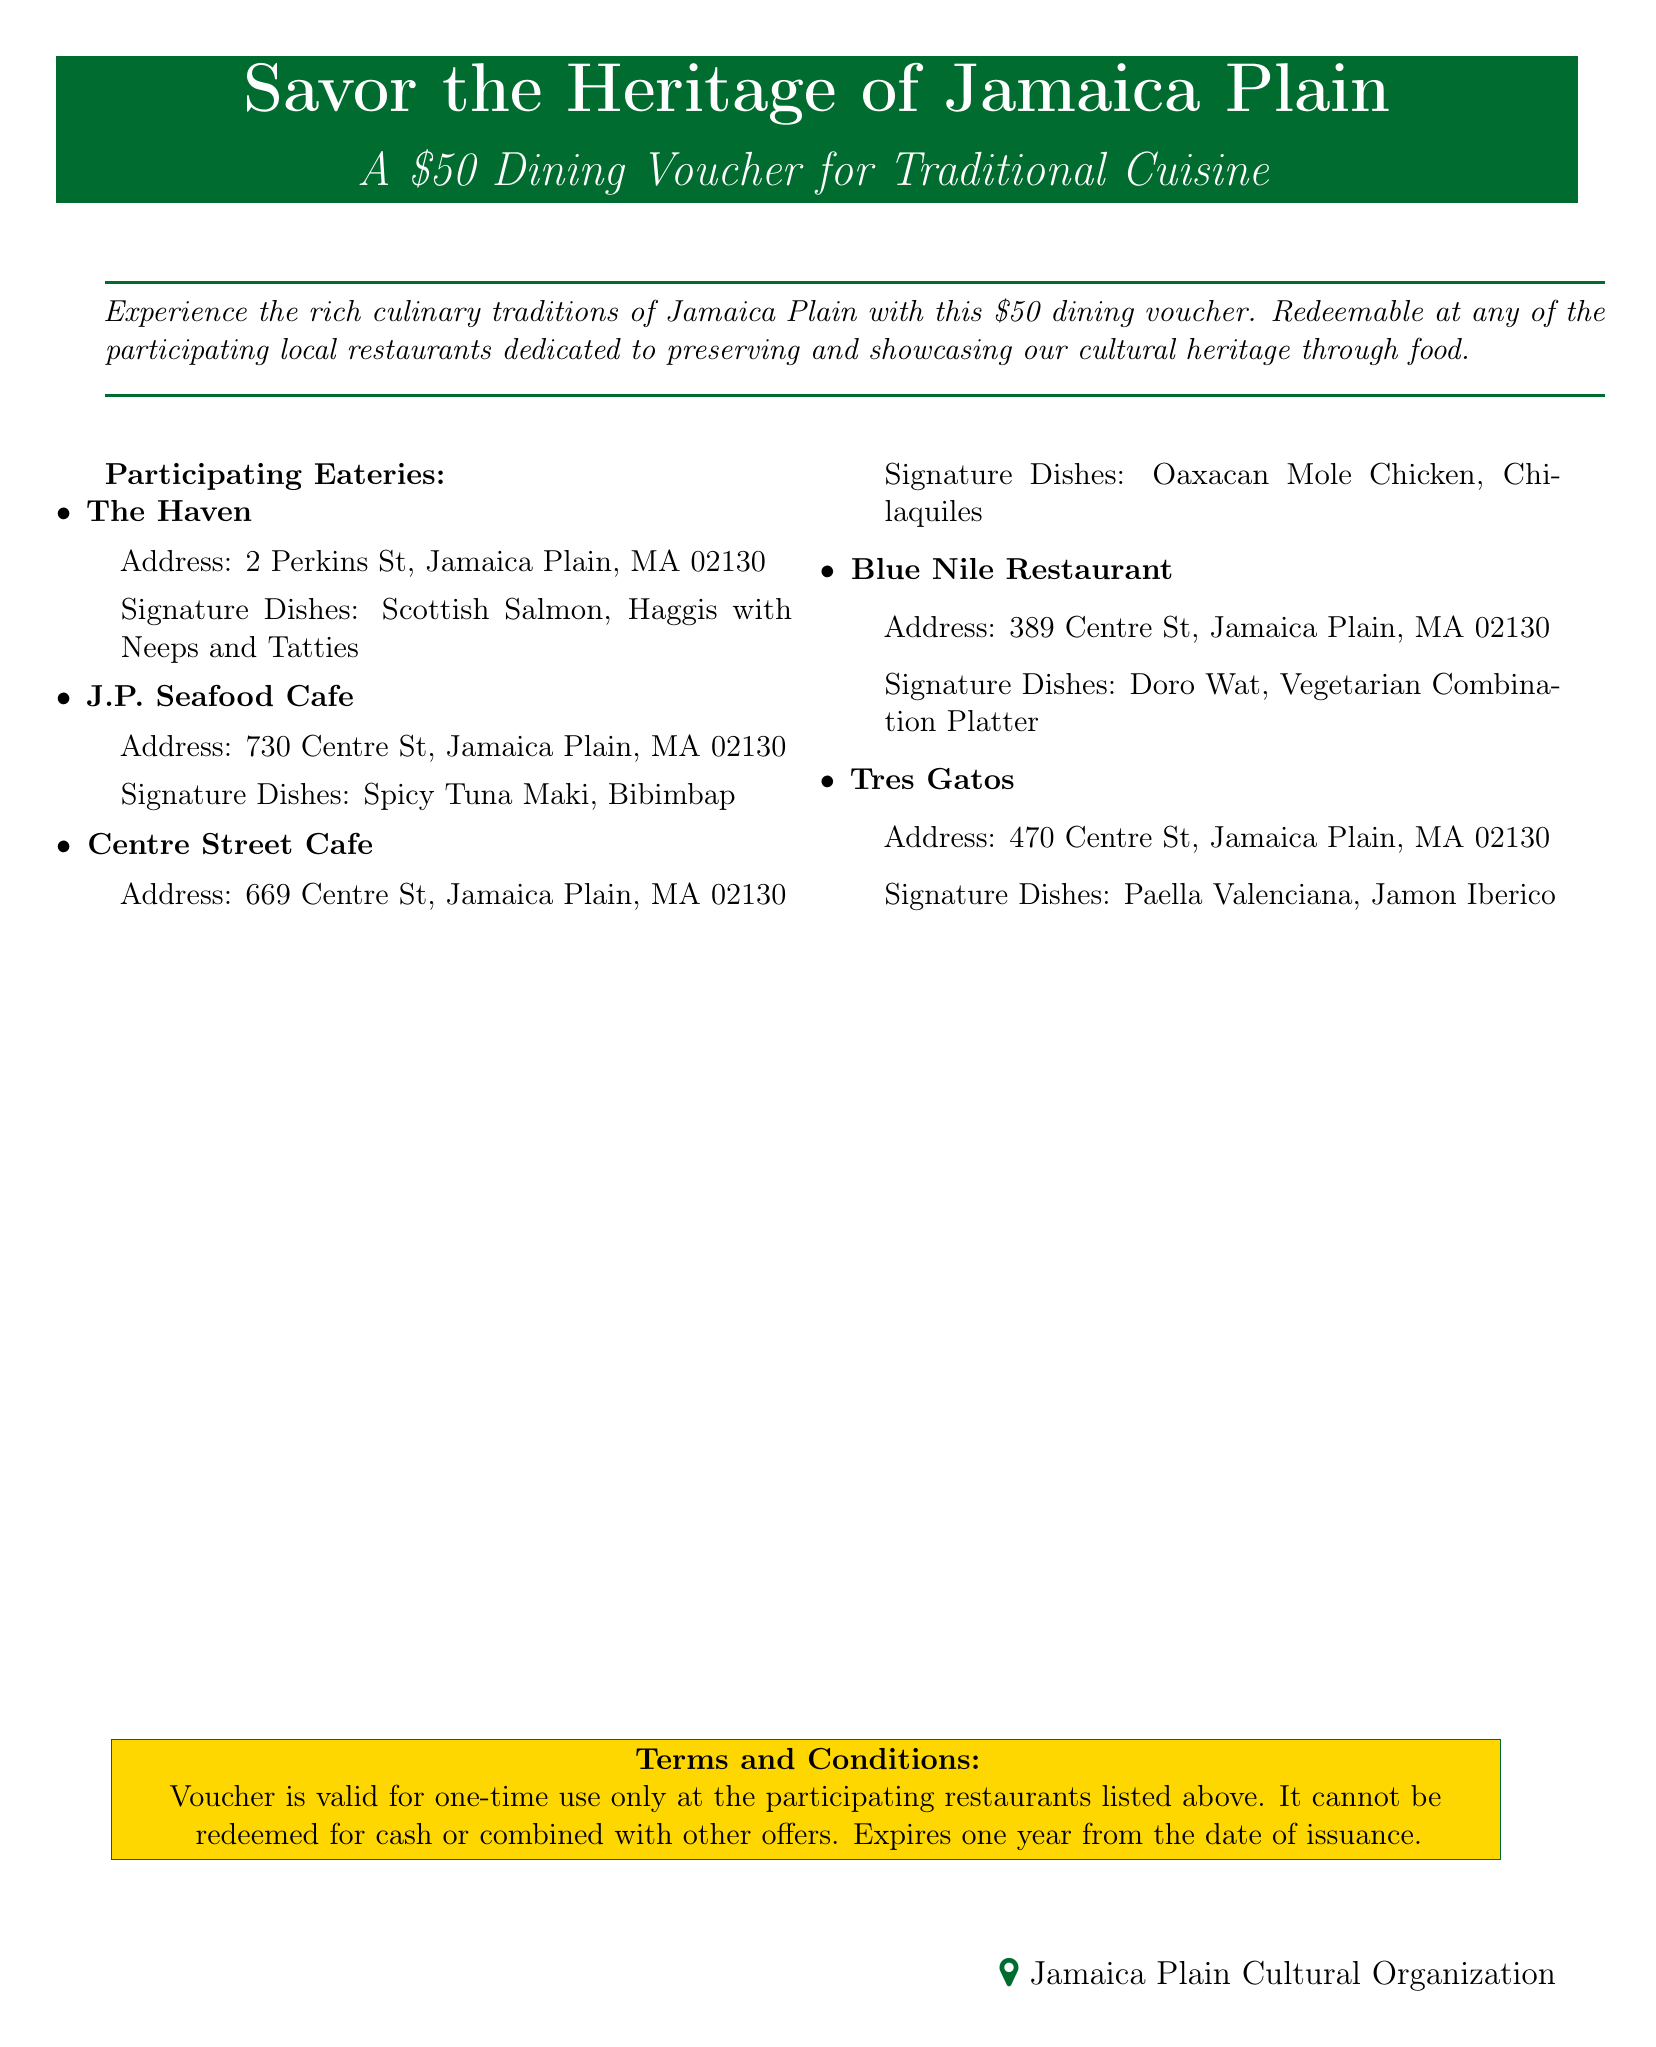What is the value of the dining voucher? The document states that the voucher is worth fifty dollars.
Answer: fifty dollars Which restaurant serves Doro Wat? Doro Wat is listed as a signature dish of Blue Nile Restaurant.
Answer: Blue Nile Restaurant How long is the voucher valid for? The document mentions that the voucher expires one year from the date of issuance.
Answer: one year What is the address of Tres Gatos? The address is provided in the listing for Tres Gatos.
Answer: 470 Centre St, Jamaica Plain, MA 02130 What is one signature dish at Centre Street Cafe? One of the signature dishes at Centre Street Cafe is Oaxacan Mole Chicken.
Answer: Oaxacan Mole Chicken Can the voucher be redeemed for cash? The terms clearly state that the voucher cannot be redeemed for cash.
Answer: No How many restaurants are listed as participating eateries? Counting the listed eateries reveals the total number of restaurants participating.
Answer: five What is the signature dish of J.P. Seafood Cafe? The document lists Spicy Tuna Maki as one of the signature dishes.
Answer: Spicy Tuna Maki What is the theme of the voucher? The document emphasizes experiencing culinary traditions.
Answer: culinary traditions 